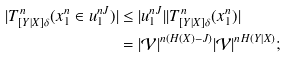<formula> <loc_0><loc_0><loc_500><loc_500>| T _ { [ Y | X ] \delta } ^ { n } ( x _ { 1 } ^ { n } \in u _ { 1 } ^ { n J } ) | & \leq | u _ { 1 } ^ { n J } | | T _ { [ Y | X ] \delta } ^ { n } ( x _ { 1 } ^ { n } ) | \\ & = | \mathcal { V } | ^ { n ( H ( X ) - J ) } | \mathcal { V } | ^ { n H ( Y | X ) } ;</formula> 